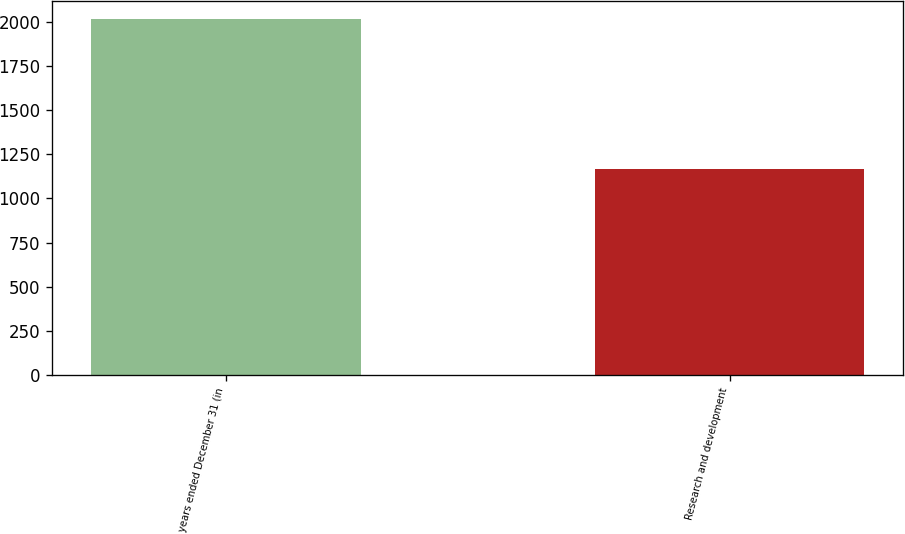Convert chart to OTSL. <chart><loc_0><loc_0><loc_500><loc_500><bar_chart><fcel>years ended December 31 (in<fcel>Research and development<nl><fcel>2013<fcel>1165<nl></chart> 